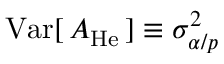Convert formula to latex. <formula><loc_0><loc_0><loc_500><loc_500>V a r [ \, A _ { H e } \, ] \equiv \sigma _ { \alpha / p } ^ { 2 }</formula> 